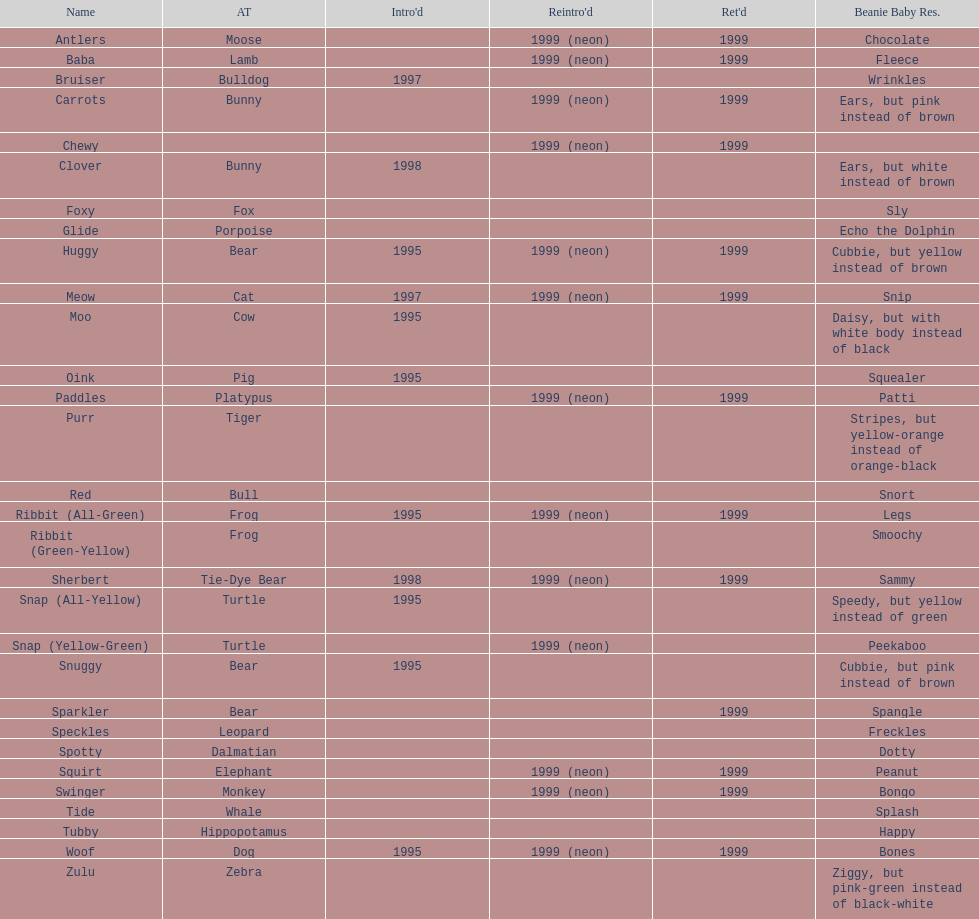Can you identify the name of the last pillow pal on this chart? Zulu. 